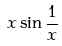Convert formula to latex. <formula><loc_0><loc_0><loc_500><loc_500>x \sin \frac { 1 } { x }</formula> 